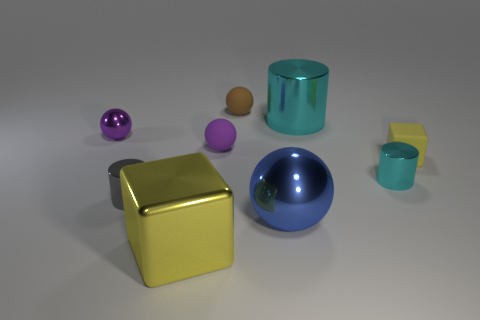The other object that is the same shape as the yellow metallic object is what size?
Make the answer very short. Small. Is the color of the small matte block the same as the tiny metallic sphere?
Your answer should be compact. No. What color is the rubber object that is in front of the purple metal ball and left of the rubber cube?
Your answer should be compact. Purple. Does the metallic ball behind the gray metallic thing have the same size as the tiny cube?
Provide a succinct answer. Yes. Are there any other things that have the same shape as the large blue metallic thing?
Your response must be concise. Yes. Do the gray object and the big object that is to the left of the brown object have the same material?
Offer a terse response. Yes. What number of purple objects are metal things or metal spheres?
Your response must be concise. 1. Are any yellow metal things visible?
Offer a very short reply. Yes. There is a cyan metal object that is behind the cyan metal object that is in front of the tiny purple metallic sphere; are there any matte blocks that are on the left side of it?
Your response must be concise. No. Is there any other thing that has the same size as the brown ball?
Your answer should be compact. Yes. 